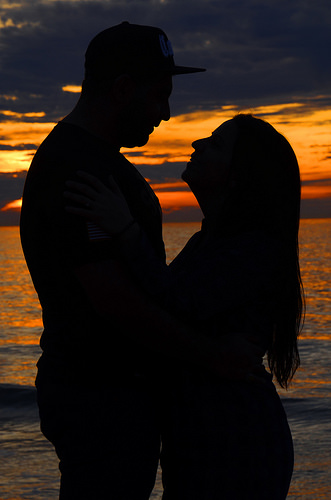<image>
Is there a lady on the man? No. The lady is not positioned on the man. They may be near each other, but the lady is not supported by or resting on top of the man. 